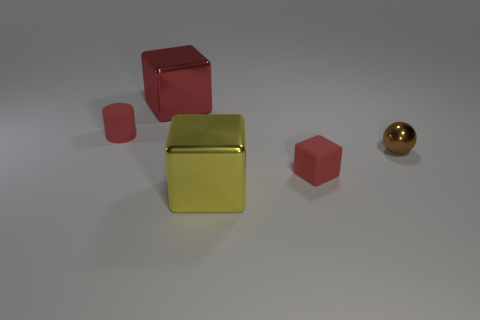Subtract all big red blocks. How many blocks are left? 2 Add 1 blue balls. How many objects exist? 6 Subtract 3 blocks. How many blocks are left? 0 Add 3 metal blocks. How many metal blocks exist? 5 Subtract all red cubes. How many cubes are left? 1 Subtract 0 blue cylinders. How many objects are left? 5 Subtract all spheres. How many objects are left? 4 Subtract all yellow blocks. Subtract all brown balls. How many blocks are left? 2 Subtract all yellow cylinders. How many cyan balls are left? 0 Subtract all tiny rubber cubes. Subtract all large yellow metal objects. How many objects are left? 3 